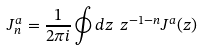Convert formula to latex. <formula><loc_0><loc_0><loc_500><loc_500>J ^ { a } _ { n } = \frac { 1 } { 2 \pi i } \oint d z \ z ^ { - 1 - n } J ^ { a } ( z )</formula> 